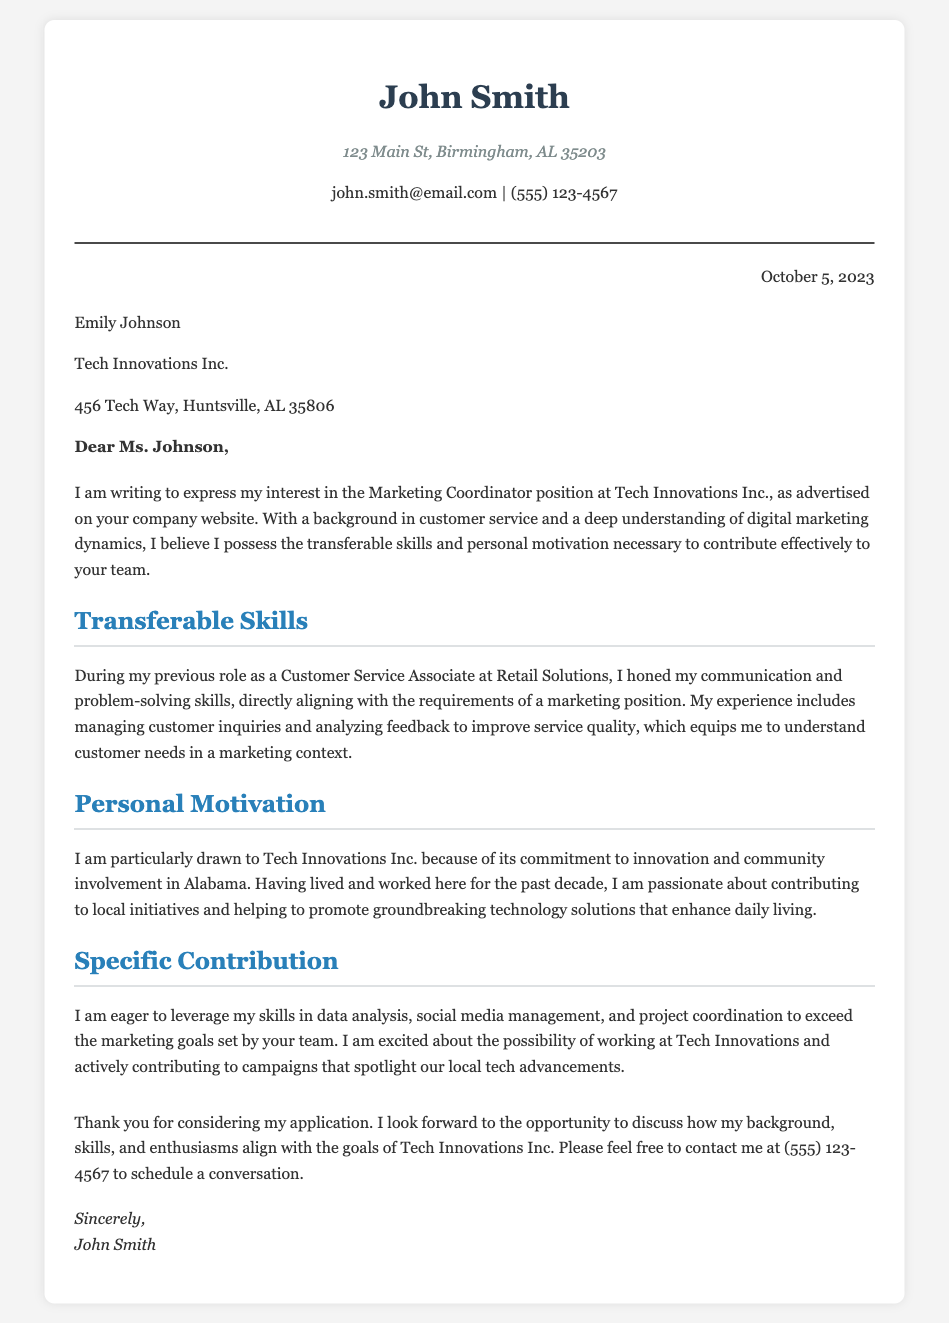What is the name of the applicant? The applicant's name is stated prominently at the top of the document.
Answer: John Smith What position is John Smith applying for? The position John Smith is applying for is mentioned in the introduction of the letter.
Answer: Marketing Coordinator Who is the employer addressed in the letter? The employer's name is provided in the employer info section of the letter.
Answer: Emily Johnson What is the date of the letter? The date is located in the date section of the document.
Answer: October 5, 2023 What company is associated with the job application? The company name is mentioned in the introduction and employer info.
Answer: Tech Innovations Inc What skills does John Smith highlight in his cover letter? The skills are indicated in the section titled Transferable Skills, describing relevant abilities.
Answer: Communication and problem-solving What motivates John Smith to work for Tech Innovations Inc.? The motivation is expressed in the Personal Motivation section of the letter.
Answer: Commitment to innovation and community involvement What specific contributions is John Smith eager to make? The specific contributions are outlined in the respective section of the letter.
Answer: Data analysis, social media management, and project coordination How does John Smith suggest contacting him? The preferred contact method is included in the closing paragraph of the letter.
Answer: (555) 123-4567 